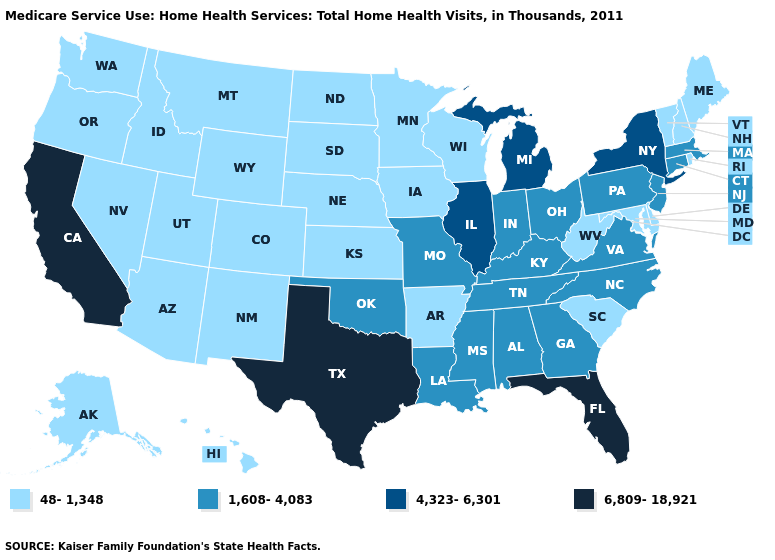Does Washington have the lowest value in the West?
Keep it brief. Yes. What is the value of Montana?
Write a very short answer. 48-1,348. Which states have the lowest value in the MidWest?
Answer briefly. Iowa, Kansas, Minnesota, Nebraska, North Dakota, South Dakota, Wisconsin. What is the highest value in the Northeast ?
Write a very short answer. 4,323-6,301. How many symbols are there in the legend?
Give a very brief answer. 4. Does New Mexico have the same value as Kansas?
Write a very short answer. Yes. What is the value of Mississippi?
Write a very short answer. 1,608-4,083. What is the value of Maryland?
Answer briefly. 48-1,348. Does Rhode Island have the highest value in the Northeast?
Be succinct. No. Does Idaho have the lowest value in the USA?
Keep it brief. Yes. Name the states that have a value in the range 6,809-18,921?
Keep it brief. California, Florida, Texas. Does the first symbol in the legend represent the smallest category?
Short answer required. Yes. Does the map have missing data?
Short answer required. No. What is the lowest value in the USA?
Quick response, please. 48-1,348. 